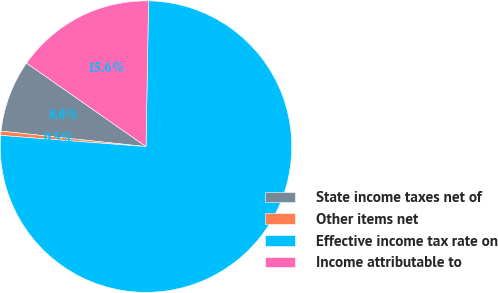Convert chart to OTSL. <chart><loc_0><loc_0><loc_500><loc_500><pie_chart><fcel>State income taxes net of<fcel>Other items net<fcel>Effective income tax rate on<fcel>Income attributable to<nl><fcel>8.02%<fcel>0.47%<fcel>75.95%<fcel>15.57%<nl></chart> 